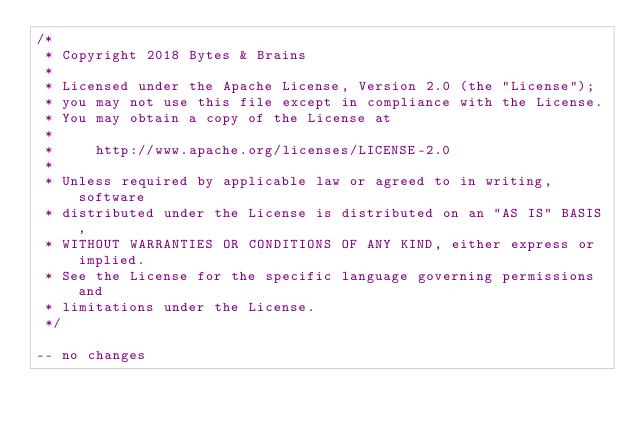<code> <loc_0><loc_0><loc_500><loc_500><_SQL_>/*
 * Copyright 2018 Bytes & Brains
 *
 * Licensed under the Apache License, Version 2.0 (the "License");
 * you may not use this file except in compliance with the License.
 * You may obtain a copy of the License at
 *
 *     http://www.apache.org/licenses/LICENSE-2.0
 *
 * Unless required by applicable law or agreed to in writing, software
 * distributed under the License is distributed on an "AS IS" BASIS,
 * WITHOUT WARRANTIES OR CONDITIONS OF ANY KIND, either express or implied.
 * See the License for the specific language governing permissions and
 * limitations under the License.
 */

-- no changes
</code> 